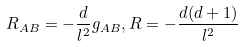<formula> <loc_0><loc_0><loc_500><loc_500>R _ { A B } = - \frac { d } { l ^ { 2 } } g _ { A B } , R = - \frac { d ( d + 1 ) } { l ^ { 2 } }</formula> 